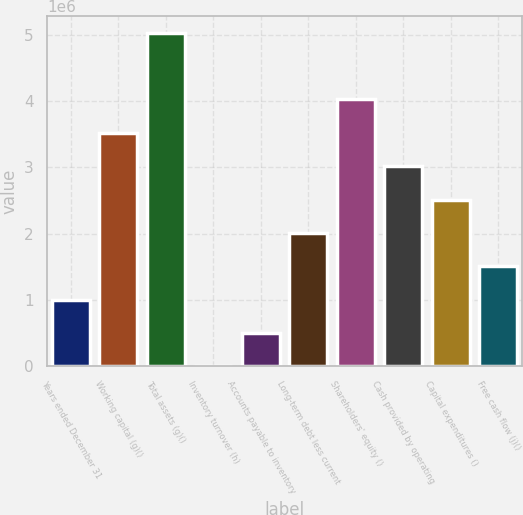Convert chart. <chart><loc_0><loc_0><loc_500><loc_500><bar_chart><fcel>Years ended December 31<fcel>Working capital (g)()<fcel>Total assets (g)()<fcel>Inventory turnover (h)<fcel>Accounts payable to inventory<fcel>Long-term debt less current<fcel>Shareholders' equity ()<fcel>Cash provided by operating<fcel>Capital expenditures ()<fcel>Free cash flow (j)()<nl><fcel>1.00639e+06<fcel>3.52237e+06<fcel>5.03195e+06<fcel>1.4<fcel>503196<fcel>2.01278e+06<fcel>4.02556e+06<fcel>3.01917e+06<fcel>2.51598e+06<fcel>1.50959e+06<nl></chart> 